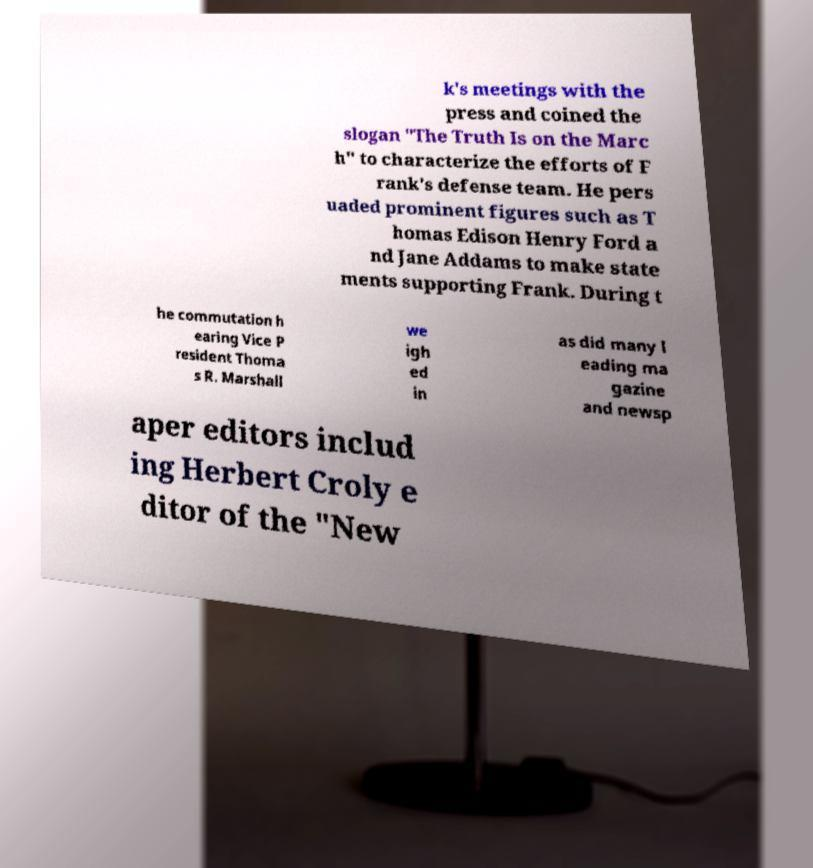I need the written content from this picture converted into text. Can you do that? k's meetings with the press and coined the slogan "The Truth Is on the Marc h" to characterize the efforts of F rank's defense team. He pers uaded prominent figures such as T homas Edison Henry Ford a nd Jane Addams to make state ments supporting Frank. During t he commutation h earing Vice P resident Thoma s R. Marshall we igh ed in as did many l eading ma gazine and newsp aper editors includ ing Herbert Croly e ditor of the "New 